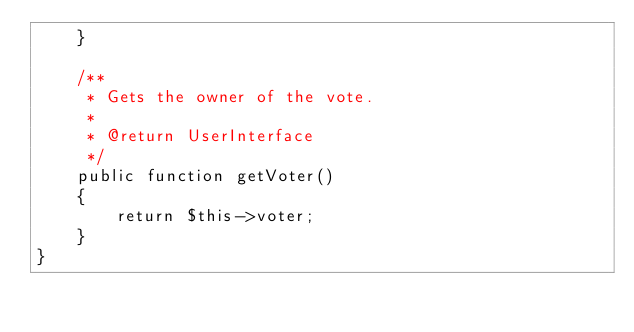<code> <loc_0><loc_0><loc_500><loc_500><_PHP_>    }

    /**
     * Gets the owner of the vote.
     *
     * @return UserInterface
     */
    public function getVoter()
    {
        return $this->voter;
    }
}
</code> 